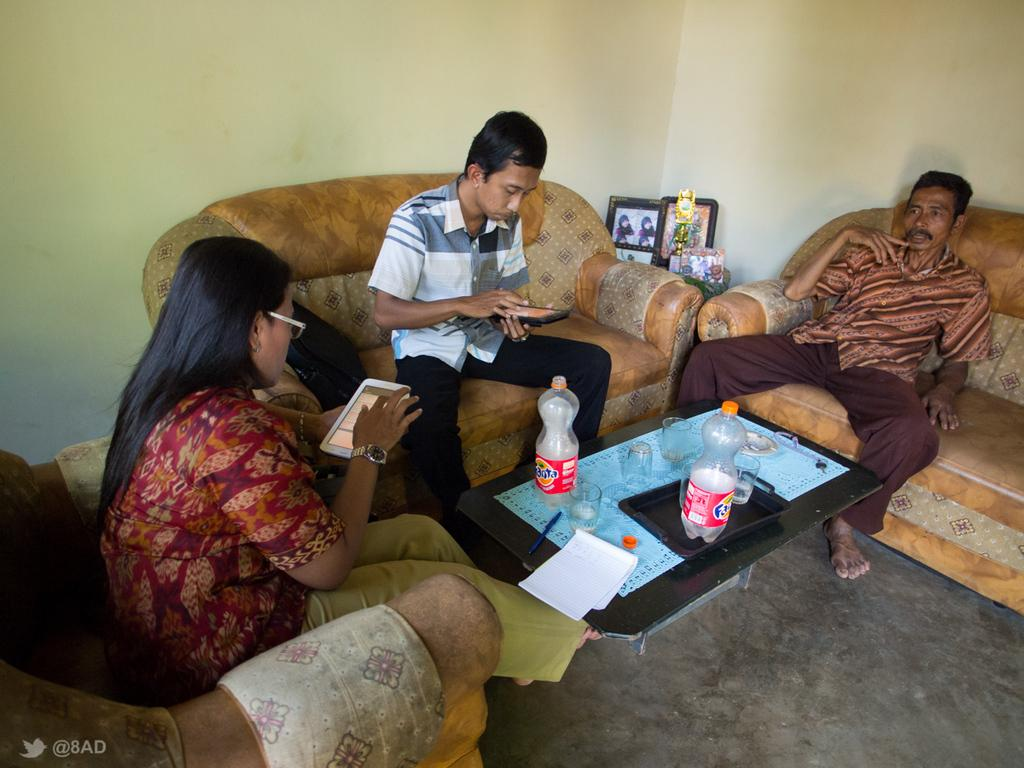How many people are in the image? There are three people in the image. What are the people doing in the image? The people are seated on chairs and holding mobile phones. What objects can be seen on the table in the image? There are bottles and glasses on the table. What type of brass instrument is being played by one of the people in the image? There is no brass instrument present in the image; the people are holding mobile phones. 